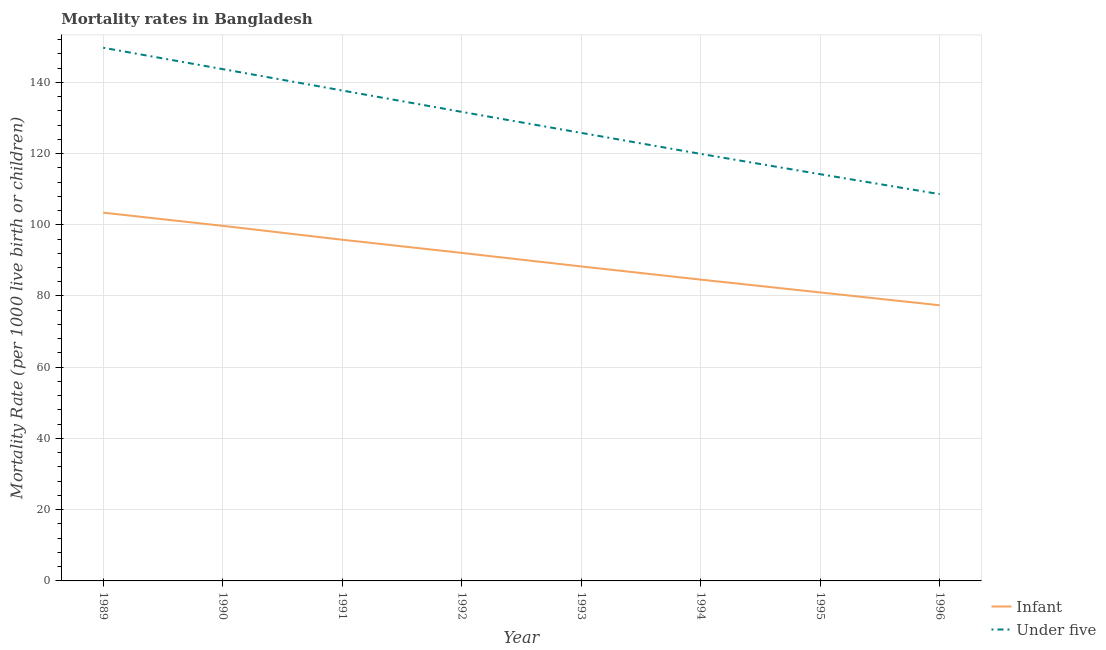How many different coloured lines are there?
Keep it short and to the point. 2. Does the line corresponding to under-5 mortality rate intersect with the line corresponding to infant mortality rate?
Provide a short and direct response. No. What is the infant mortality rate in 1991?
Offer a very short reply. 95.8. Across all years, what is the maximum infant mortality rate?
Offer a very short reply. 103.4. Across all years, what is the minimum infant mortality rate?
Give a very brief answer. 77.4. In which year was the under-5 mortality rate minimum?
Ensure brevity in your answer.  1996. What is the total under-5 mortality rate in the graph?
Make the answer very short. 1031.3. What is the difference between the infant mortality rate in 1993 and that in 1996?
Offer a very short reply. 10.9. What is the difference between the under-5 mortality rate in 1989 and the infant mortality rate in 1995?
Offer a very short reply. 68.7. What is the average under-5 mortality rate per year?
Offer a terse response. 128.91. In the year 1992, what is the difference between the under-5 mortality rate and infant mortality rate?
Offer a very short reply. 39.6. In how many years, is the infant mortality rate greater than 40?
Make the answer very short. 8. What is the ratio of the under-5 mortality rate in 1994 to that in 1996?
Give a very brief answer. 1.1. What is the difference between the highest and the second highest infant mortality rate?
Ensure brevity in your answer.  3.7. What is the difference between the highest and the lowest under-5 mortality rate?
Provide a short and direct response. 41.1. Does the infant mortality rate monotonically increase over the years?
Keep it short and to the point. No. What is the difference between two consecutive major ticks on the Y-axis?
Offer a very short reply. 20. Are the values on the major ticks of Y-axis written in scientific E-notation?
Ensure brevity in your answer.  No. Does the graph contain grids?
Offer a terse response. Yes. Where does the legend appear in the graph?
Keep it short and to the point. Bottom right. How are the legend labels stacked?
Provide a short and direct response. Vertical. What is the title of the graph?
Keep it short and to the point. Mortality rates in Bangladesh. Does "Under-5(male)" appear as one of the legend labels in the graph?
Offer a very short reply. No. What is the label or title of the Y-axis?
Make the answer very short. Mortality Rate (per 1000 live birth or children). What is the Mortality Rate (per 1000 live birth or children) of Infant in 1989?
Keep it short and to the point. 103.4. What is the Mortality Rate (per 1000 live birth or children) of Under five in 1989?
Keep it short and to the point. 149.7. What is the Mortality Rate (per 1000 live birth or children) in Infant in 1990?
Keep it short and to the point. 99.7. What is the Mortality Rate (per 1000 live birth or children) of Under five in 1990?
Provide a succinct answer. 143.7. What is the Mortality Rate (per 1000 live birth or children) in Infant in 1991?
Give a very brief answer. 95.8. What is the Mortality Rate (per 1000 live birth or children) in Under five in 1991?
Make the answer very short. 137.7. What is the Mortality Rate (per 1000 live birth or children) of Infant in 1992?
Make the answer very short. 92.1. What is the Mortality Rate (per 1000 live birth or children) of Under five in 1992?
Your answer should be compact. 131.7. What is the Mortality Rate (per 1000 live birth or children) of Infant in 1993?
Your response must be concise. 88.3. What is the Mortality Rate (per 1000 live birth or children) of Under five in 1993?
Your answer should be very brief. 125.8. What is the Mortality Rate (per 1000 live birth or children) in Infant in 1994?
Your answer should be very brief. 84.6. What is the Mortality Rate (per 1000 live birth or children) of Under five in 1994?
Provide a succinct answer. 119.9. What is the Mortality Rate (per 1000 live birth or children) in Under five in 1995?
Your response must be concise. 114.2. What is the Mortality Rate (per 1000 live birth or children) of Infant in 1996?
Your response must be concise. 77.4. What is the Mortality Rate (per 1000 live birth or children) in Under five in 1996?
Give a very brief answer. 108.6. Across all years, what is the maximum Mortality Rate (per 1000 live birth or children) in Infant?
Your answer should be very brief. 103.4. Across all years, what is the maximum Mortality Rate (per 1000 live birth or children) in Under five?
Provide a short and direct response. 149.7. Across all years, what is the minimum Mortality Rate (per 1000 live birth or children) of Infant?
Offer a terse response. 77.4. Across all years, what is the minimum Mortality Rate (per 1000 live birth or children) of Under five?
Make the answer very short. 108.6. What is the total Mortality Rate (per 1000 live birth or children) in Infant in the graph?
Provide a succinct answer. 722.3. What is the total Mortality Rate (per 1000 live birth or children) of Under five in the graph?
Offer a very short reply. 1031.3. What is the difference between the Mortality Rate (per 1000 live birth or children) in Infant in 1989 and that in 1990?
Your response must be concise. 3.7. What is the difference between the Mortality Rate (per 1000 live birth or children) of Under five in 1989 and that in 1990?
Give a very brief answer. 6. What is the difference between the Mortality Rate (per 1000 live birth or children) of Infant in 1989 and that in 1991?
Your response must be concise. 7.6. What is the difference between the Mortality Rate (per 1000 live birth or children) in Under five in 1989 and that in 1991?
Offer a terse response. 12. What is the difference between the Mortality Rate (per 1000 live birth or children) in Under five in 1989 and that in 1992?
Make the answer very short. 18. What is the difference between the Mortality Rate (per 1000 live birth or children) of Infant in 1989 and that in 1993?
Ensure brevity in your answer.  15.1. What is the difference between the Mortality Rate (per 1000 live birth or children) in Under five in 1989 and that in 1993?
Ensure brevity in your answer.  23.9. What is the difference between the Mortality Rate (per 1000 live birth or children) of Under five in 1989 and that in 1994?
Your answer should be very brief. 29.8. What is the difference between the Mortality Rate (per 1000 live birth or children) in Infant in 1989 and that in 1995?
Provide a short and direct response. 22.4. What is the difference between the Mortality Rate (per 1000 live birth or children) in Under five in 1989 and that in 1995?
Your response must be concise. 35.5. What is the difference between the Mortality Rate (per 1000 live birth or children) of Under five in 1989 and that in 1996?
Ensure brevity in your answer.  41.1. What is the difference between the Mortality Rate (per 1000 live birth or children) in Under five in 1990 and that in 1993?
Your response must be concise. 17.9. What is the difference between the Mortality Rate (per 1000 live birth or children) in Under five in 1990 and that in 1994?
Provide a short and direct response. 23.8. What is the difference between the Mortality Rate (per 1000 live birth or children) in Infant in 1990 and that in 1995?
Your answer should be very brief. 18.7. What is the difference between the Mortality Rate (per 1000 live birth or children) in Under five in 1990 and that in 1995?
Give a very brief answer. 29.5. What is the difference between the Mortality Rate (per 1000 live birth or children) in Infant in 1990 and that in 1996?
Give a very brief answer. 22.3. What is the difference between the Mortality Rate (per 1000 live birth or children) of Under five in 1990 and that in 1996?
Keep it short and to the point. 35.1. What is the difference between the Mortality Rate (per 1000 live birth or children) of Infant in 1991 and that in 1992?
Make the answer very short. 3.7. What is the difference between the Mortality Rate (per 1000 live birth or children) of Infant in 1991 and that in 1994?
Your answer should be very brief. 11.2. What is the difference between the Mortality Rate (per 1000 live birth or children) of Infant in 1991 and that in 1995?
Provide a short and direct response. 14.8. What is the difference between the Mortality Rate (per 1000 live birth or children) of Under five in 1991 and that in 1995?
Keep it short and to the point. 23.5. What is the difference between the Mortality Rate (per 1000 live birth or children) of Infant in 1991 and that in 1996?
Your response must be concise. 18.4. What is the difference between the Mortality Rate (per 1000 live birth or children) of Under five in 1991 and that in 1996?
Offer a terse response. 29.1. What is the difference between the Mortality Rate (per 1000 live birth or children) of Infant in 1992 and that in 1993?
Provide a succinct answer. 3.8. What is the difference between the Mortality Rate (per 1000 live birth or children) in Under five in 1992 and that in 1993?
Make the answer very short. 5.9. What is the difference between the Mortality Rate (per 1000 live birth or children) of Infant in 1992 and that in 1995?
Your answer should be very brief. 11.1. What is the difference between the Mortality Rate (per 1000 live birth or children) in Infant in 1992 and that in 1996?
Your answer should be compact. 14.7. What is the difference between the Mortality Rate (per 1000 live birth or children) in Under five in 1992 and that in 1996?
Give a very brief answer. 23.1. What is the difference between the Mortality Rate (per 1000 live birth or children) of Infant in 1993 and that in 1994?
Give a very brief answer. 3.7. What is the difference between the Mortality Rate (per 1000 live birth or children) in Under five in 1993 and that in 1995?
Provide a short and direct response. 11.6. What is the difference between the Mortality Rate (per 1000 live birth or children) of Infant in 1993 and that in 1996?
Offer a very short reply. 10.9. What is the difference between the Mortality Rate (per 1000 live birth or children) of Infant in 1994 and that in 1995?
Your response must be concise. 3.6. What is the difference between the Mortality Rate (per 1000 live birth or children) in Under five in 1994 and that in 1996?
Your response must be concise. 11.3. What is the difference between the Mortality Rate (per 1000 live birth or children) of Infant in 1995 and that in 1996?
Offer a terse response. 3.6. What is the difference between the Mortality Rate (per 1000 live birth or children) in Under five in 1995 and that in 1996?
Your answer should be compact. 5.6. What is the difference between the Mortality Rate (per 1000 live birth or children) of Infant in 1989 and the Mortality Rate (per 1000 live birth or children) of Under five in 1990?
Provide a short and direct response. -40.3. What is the difference between the Mortality Rate (per 1000 live birth or children) of Infant in 1989 and the Mortality Rate (per 1000 live birth or children) of Under five in 1991?
Ensure brevity in your answer.  -34.3. What is the difference between the Mortality Rate (per 1000 live birth or children) of Infant in 1989 and the Mortality Rate (per 1000 live birth or children) of Under five in 1992?
Provide a succinct answer. -28.3. What is the difference between the Mortality Rate (per 1000 live birth or children) of Infant in 1989 and the Mortality Rate (per 1000 live birth or children) of Under five in 1993?
Give a very brief answer. -22.4. What is the difference between the Mortality Rate (per 1000 live birth or children) in Infant in 1989 and the Mortality Rate (per 1000 live birth or children) in Under five in 1994?
Your answer should be compact. -16.5. What is the difference between the Mortality Rate (per 1000 live birth or children) of Infant in 1990 and the Mortality Rate (per 1000 live birth or children) of Under five in 1991?
Your response must be concise. -38. What is the difference between the Mortality Rate (per 1000 live birth or children) of Infant in 1990 and the Mortality Rate (per 1000 live birth or children) of Under five in 1992?
Provide a succinct answer. -32. What is the difference between the Mortality Rate (per 1000 live birth or children) in Infant in 1990 and the Mortality Rate (per 1000 live birth or children) in Under five in 1993?
Give a very brief answer. -26.1. What is the difference between the Mortality Rate (per 1000 live birth or children) of Infant in 1990 and the Mortality Rate (per 1000 live birth or children) of Under five in 1994?
Keep it short and to the point. -20.2. What is the difference between the Mortality Rate (per 1000 live birth or children) of Infant in 1990 and the Mortality Rate (per 1000 live birth or children) of Under five in 1995?
Offer a very short reply. -14.5. What is the difference between the Mortality Rate (per 1000 live birth or children) of Infant in 1991 and the Mortality Rate (per 1000 live birth or children) of Under five in 1992?
Your answer should be compact. -35.9. What is the difference between the Mortality Rate (per 1000 live birth or children) in Infant in 1991 and the Mortality Rate (per 1000 live birth or children) in Under five in 1993?
Your response must be concise. -30. What is the difference between the Mortality Rate (per 1000 live birth or children) in Infant in 1991 and the Mortality Rate (per 1000 live birth or children) in Under five in 1994?
Your answer should be compact. -24.1. What is the difference between the Mortality Rate (per 1000 live birth or children) of Infant in 1991 and the Mortality Rate (per 1000 live birth or children) of Under five in 1995?
Give a very brief answer. -18.4. What is the difference between the Mortality Rate (per 1000 live birth or children) in Infant in 1992 and the Mortality Rate (per 1000 live birth or children) in Under five in 1993?
Make the answer very short. -33.7. What is the difference between the Mortality Rate (per 1000 live birth or children) of Infant in 1992 and the Mortality Rate (per 1000 live birth or children) of Under five in 1994?
Give a very brief answer. -27.8. What is the difference between the Mortality Rate (per 1000 live birth or children) of Infant in 1992 and the Mortality Rate (per 1000 live birth or children) of Under five in 1995?
Provide a succinct answer. -22.1. What is the difference between the Mortality Rate (per 1000 live birth or children) of Infant in 1992 and the Mortality Rate (per 1000 live birth or children) of Under five in 1996?
Your answer should be very brief. -16.5. What is the difference between the Mortality Rate (per 1000 live birth or children) in Infant in 1993 and the Mortality Rate (per 1000 live birth or children) in Under five in 1994?
Your answer should be very brief. -31.6. What is the difference between the Mortality Rate (per 1000 live birth or children) in Infant in 1993 and the Mortality Rate (per 1000 live birth or children) in Under five in 1995?
Your answer should be compact. -25.9. What is the difference between the Mortality Rate (per 1000 live birth or children) in Infant in 1993 and the Mortality Rate (per 1000 live birth or children) in Under five in 1996?
Offer a terse response. -20.3. What is the difference between the Mortality Rate (per 1000 live birth or children) of Infant in 1994 and the Mortality Rate (per 1000 live birth or children) of Under five in 1995?
Your answer should be compact. -29.6. What is the difference between the Mortality Rate (per 1000 live birth or children) in Infant in 1995 and the Mortality Rate (per 1000 live birth or children) in Under five in 1996?
Ensure brevity in your answer.  -27.6. What is the average Mortality Rate (per 1000 live birth or children) of Infant per year?
Your answer should be compact. 90.29. What is the average Mortality Rate (per 1000 live birth or children) of Under five per year?
Your response must be concise. 128.91. In the year 1989, what is the difference between the Mortality Rate (per 1000 live birth or children) in Infant and Mortality Rate (per 1000 live birth or children) in Under five?
Your answer should be compact. -46.3. In the year 1990, what is the difference between the Mortality Rate (per 1000 live birth or children) in Infant and Mortality Rate (per 1000 live birth or children) in Under five?
Provide a short and direct response. -44. In the year 1991, what is the difference between the Mortality Rate (per 1000 live birth or children) in Infant and Mortality Rate (per 1000 live birth or children) in Under five?
Make the answer very short. -41.9. In the year 1992, what is the difference between the Mortality Rate (per 1000 live birth or children) of Infant and Mortality Rate (per 1000 live birth or children) of Under five?
Your response must be concise. -39.6. In the year 1993, what is the difference between the Mortality Rate (per 1000 live birth or children) of Infant and Mortality Rate (per 1000 live birth or children) of Under five?
Keep it short and to the point. -37.5. In the year 1994, what is the difference between the Mortality Rate (per 1000 live birth or children) in Infant and Mortality Rate (per 1000 live birth or children) in Under five?
Provide a succinct answer. -35.3. In the year 1995, what is the difference between the Mortality Rate (per 1000 live birth or children) in Infant and Mortality Rate (per 1000 live birth or children) in Under five?
Give a very brief answer. -33.2. In the year 1996, what is the difference between the Mortality Rate (per 1000 live birth or children) of Infant and Mortality Rate (per 1000 live birth or children) of Under five?
Ensure brevity in your answer.  -31.2. What is the ratio of the Mortality Rate (per 1000 live birth or children) in Infant in 1989 to that in 1990?
Make the answer very short. 1.04. What is the ratio of the Mortality Rate (per 1000 live birth or children) of Under five in 1989 to that in 1990?
Offer a terse response. 1.04. What is the ratio of the Mortality Rate (per 1000 live birth or children) in Infant in 1989 to that in 1991?
Provide a short and direct response. 1.08. What is the ratio of the Mortality Rate (per 1000 live birth or children) in Under five in 1989 to that in 1991?
Your answer should be very brief. 1.09. What is the ratio of the Mortality Rate (per 1000 live birth or children) in Infant in 1989 to that in 1992?
Ensure brevity in your answer.  1.12. What is the ratio of the Mortality Rate (per 1000 live birth or children) of Under five in 1989 to that in 1992?
Offer a very short reply. 1.14. What is the ratio of the Mortality Rate (per 1000 live birth or children) in Infant in 1989 to that in 1993?
Make the answer very short. 1.17. What is the ratio of the Mortality Rate (per 1000 live birth or children) in Under five in 1989 to that in 1993?
Provide a short and direct response. 1.19. What is the ratio of the Mortality Rate (per 1000 live birth or children) in Infant in 1989 to that in 1994?
Ensure brevity in your answer.  1.22. What is the ratio of the Mortality Rate (per 1000 live birth or children) of Under five in 1989 to that in 1994?
Your answer should be compact. 1.25. What is the ratio of the Mortality Rate (per 1000 live birth or children) of Infant in 1989 to that in 1995?
Offer a very short reply. 1.28. What is the ratio of the Mortality Rate (per 1000 live birth or children) in Under five in 1989 to that in 1995?
Make the answer very short. 1.31. What is the ratio of the Mortality Rate (per 1000 live birth or children) of Infant in 1989 to that in 1996?
Ensure brevity in your answer.  1.34. What is the ratio of the Mortality Rate (per 1000 live birth or children) in Under five in 1989 to that in 1996?
Provide a short and direct response. 1.38. What is the ratio of the Mortality Rate (per 1000 live birth or children) in Infant in 1990 to that in 1991?
Ensure brevity in your answer.  1.04. What is the ratio of the Mortality Rate (per 1000 live birth or children) in Under five in 1990 to that in 1991?
Your response must be concise. 1.04. What is the ratio of the Mortality Rate (per 1000 live birth or children) in Infant in 1990 to that in 1992?
Your response must be concise. 1.08. What is the ratio of the Mortality Rate (per 1000 live birth or children) in Under five in 1990 to that in 1992?
Give a very brief answer. 1.09. What is the ratio of the Mortality Rate (per 1000 live birth or children) in Infant in 1990 to that in 1993?
Give a very brief answer. 1.13. What is the ratio of the Mortality Rate (per 1000 live birth or children) of Under five in 1990 to that in 1993?
Your answer should be compact. 1.14. What is the ratio of the Mortality Rate (per 1000 live birth or children) of Infant in 1990 to that in 1994?
Provide a succinct answer. 1.18. What is the ratio of the Mortality Rate (per 1000 live birth or children) in Under five in 1990 to that in 1994?
Offer a terse response. 1.2. What is the ratio of the Mortality Rate (per 1000 live birth or children) in Infant in 1990 to that in 1995?
Make the answer very short. 1.23. What is the ratio of the Mortality Rate (per 1000 live birth or children) in Under five in 1990 to that in 1995?
Offer a very short reply. 1.26. What is the ratio of the Mortality Rate (per 1000 live birth or children) of Infant in 1990 to that in 1996?
Your answer should be very brief. 1.29. What is the ratio of the Mortality Rate (per 1000 live birth or children) in Under five in 1990 to that in 1996?
Offer a terse response. 1.32. What is the ratio of the Mortality Rate (per 1000 live birth or children) of Infant in 1991 to that in 1992?
Ensure brevity in your answer.  1.04. What is the ratio of the Mortality Rate (per 1000 live birth or children) of Under five in 1991 to that in 1992?
Provide a succinct answer. 1.05. What is the ratio of the Mortality Rate (per 1000 live birth or children) of Infant in 1991 to that in 1993?
Your answer should be very brief. 1.08. What is the ratio of the Mortality Rate (per 1000 live birth or children) of Under five in 1991 to that in 1993?
Make the answer very short. 1.09. What is the ratio of the Mortality Rate (per 1000 live birth or children) in Infant in 1991 to that in 1994?
Your answer should be compact. 1.13. What is the ratio of the Mortality Rate (per 1000 live birth or children) of Under five in 1991 to that in 1994?
Your answer should be very brief. 1.15. What is the ratio of the Mortality Rate (per 1000 live birth or children) in Infant in 1991 to that in 1995?
Your response must be concise. 1.18. What is the ratio of the Mortality Rate (per 1000 live birth or children) in Under five in 1991 to that in 1995?
Make the answer very short. 1.21. What is the ratio of the Mortality Rate (per 1000 live birth or children) in Infant in 1991 to that in 1996?
Ensure brevity in your answer.  1.24. What is the ratio of the Mortality Rate (per 1000 live birth or children) of Under five in 1991 to that in 1996?
Provide a short and direct response. 1.27. What is the ratio of the Mortality Rate (per 1000 live birth or children) of Infant in 1992 to that in 1993?
Your answer should be compact. 1.04. What is the ratio of the Mortality Rate (per 1000 live birth or children) in Under five in 1992 to that in 1993?
Offer a very short reply. 1.05. What is the ratio of the Mortality Rate (per 1000 live birth or children) in Infant in 1992 to that in 1994?
Make the answer very short. 1.09. What is the ratio of the Mortality Rate (per 1000 live birth or children) of Under five in 1992 to that in 1994?
Provide a succinct answer. 1.1. What is the ratio of the Mortality Rate (per 1000 live birth or children) in Infant in 1992 to that in 1995?
Your answer should be very brief. 1.14. What is the ratio of the Mortality Rate (per 1000 live birth or children) in Under five in 1992 to that in 1995?
Your response must be concise. 1.15. What is the ratio of the Mortality Rate (per 1000 live birth or children) in Infant in 1992 to that in 1996?
Provide a short and direct response. 1.19. What is the ratio of the Mortality Rate (per 1000 live birth or children) in Under five in 1992 to that in 1996?
Offer a terse response. 1.21. What is the ratio of the Mortality Rate (per 1000 live birth or children) in Infant in 1993 to that in 1994?
Offer a terse response. 1.04. What is the ratio of the Mortality Rate (per 1000 live birth or children) in Under five in 1993 to that in 1994?
Make the answer very short. 1.05. What is the ratio of the Mortality Rate (per 1000 live birth or children) in Infant in 1993 to that in 1995?
Your answer should be very brief. 1.09. What is the ratio of the Mortality Rate (per 1000 live birth or children) of Under five in 1993 to that in 1995?
Keep it short and to the point. 1.1. What is the ratio of the Mortality Rate (per 1000 live birth or children) in Infant in 1993 to that in 1996?
Ensure brevity in your answer.  1.14. What is the ratio of the Mortality Rate (per 1000 live birth or children) in Under five in 1993 to that in 1996?
Your answer should be compact. 1.16. What is the ratio of the Mortality Rate (per 1000 live birth or children) in Infant in 1994 to that in 1995?
Make the answer very short. 1.04. What is the ratio of the Mortality Rate (per 1000 live birth or children) in Under five in 1994 to that in 1995?
Your response must be concise. 1.05. What is the ratio of the Mortality Rate (per 1000 live birth or children) of Infant in 1994 to that in 1996?
Offer a very short reply. 1.09. What is the ratio of the Mortality Rate (per 1000 live birth or children) in Under five in 1994 to that in 1996?
Make the answer very short. 1.1. What is the ratio of the Mortality Rate (per 1000 live birth or children) of Infant in 1995 to that in 1996?
Provide a succinct answer. 1.05. What is the ratio of the Mortality Rate (per 1000 live birth or children) of Under five in 1995 to that in 1996?
Ensure brevity in your answer.  1.05. What is the difference between the highest and the second highest Mortality Rate (per 1000 live birth or children) of Infant?
Provide a succinct answer. 3.7. What is the difference between the highest and the lowest Mortality Rate (per 1000 live birth or children) of Under five?
Provide a short and direct response. 41.1. 